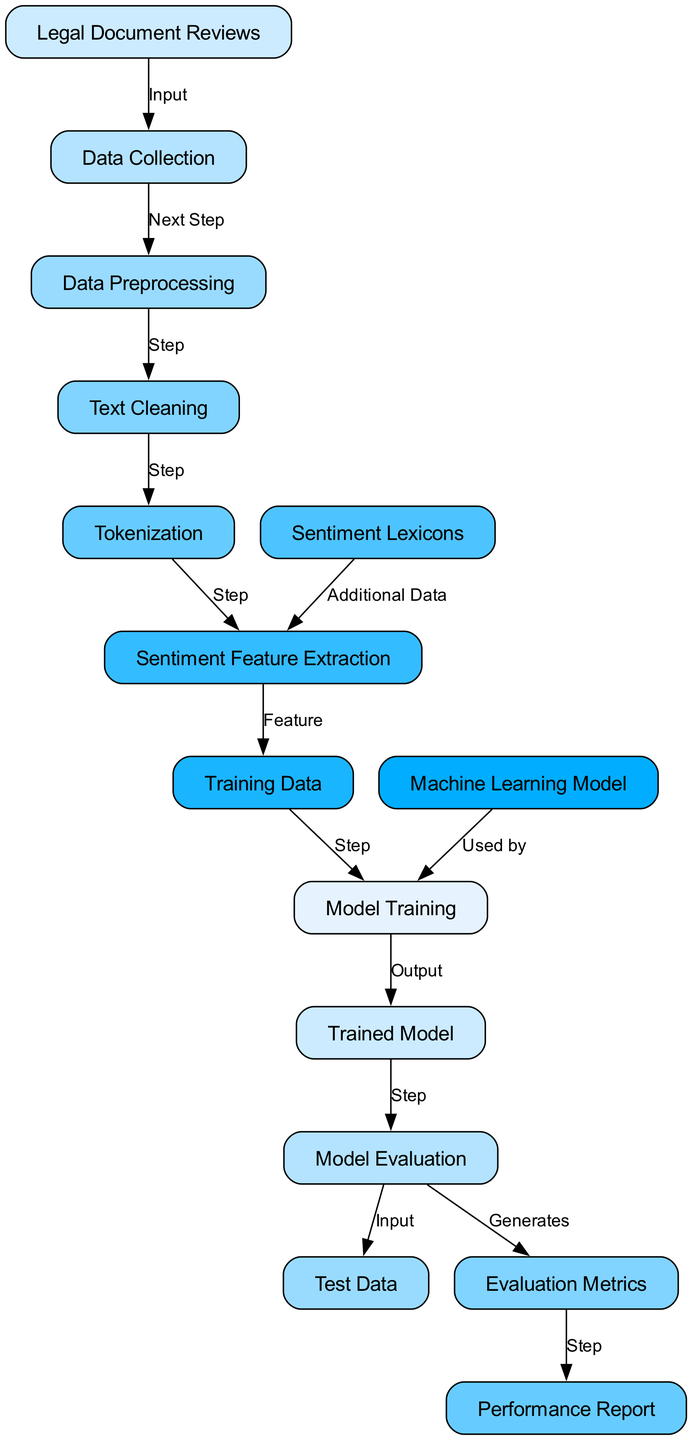What is the first step in the process? The diagram indicates that the first step, represented by the "Legal Document Reviews" node, is the input that leads to the next step of "Data Collection".
Answer: Data Collection How many nodes are in the diagram? By counting the labeled nodes present in the diagram, there are a total of 15 nodes listed.
Answer: 15 Which node contains "Model Evaluation"? The node labeled "Model Evaluation" is found as node number 12 in the diagram, indicating its role in the process after the trained model.
Answer: 12 What follows "Trained Model" in the diagram? The "Trained Model," which is node 11, leads next to "Model Evaluation," indicating an evaluation step after training.
Answer: Model Evaluation Which two nodes are connected by the label "Generates"? The nodes "Model Evaluation" and "Evaluation Metrics" are connected by the label "Generates", showing that evaluation generates metrics for assessment.
Answer: Evaluation Metrics What is the relationship between "Sentiment Lexicons" and "Sentiment Feature Extraction"? The "Sentiment Lexicons" node leads to "Sentiment Feature Extraction," indicating that lexicons provide additional data necessary for extracting sentiment features from the text.
Answer: Additional Data How many edges are present in the diagram? Examining the connections between nodes (edges), it is evident that there are a total of 14 edges present in the diagram that represent the flow of the process.
Answer: 14 Which node serves as the input for "Test Data"? The "Test Data" node is fed by "Model Evaluation," indicating that after evaluation, test data serves to assess the model's performance.
Answer: Model Evaluation What step directly follows "Model Training"? After the "Model Training" step, represented by node number 10, the process continues to "Trained Model," which signifies the output of the training phase.
Answer: Trained Model 